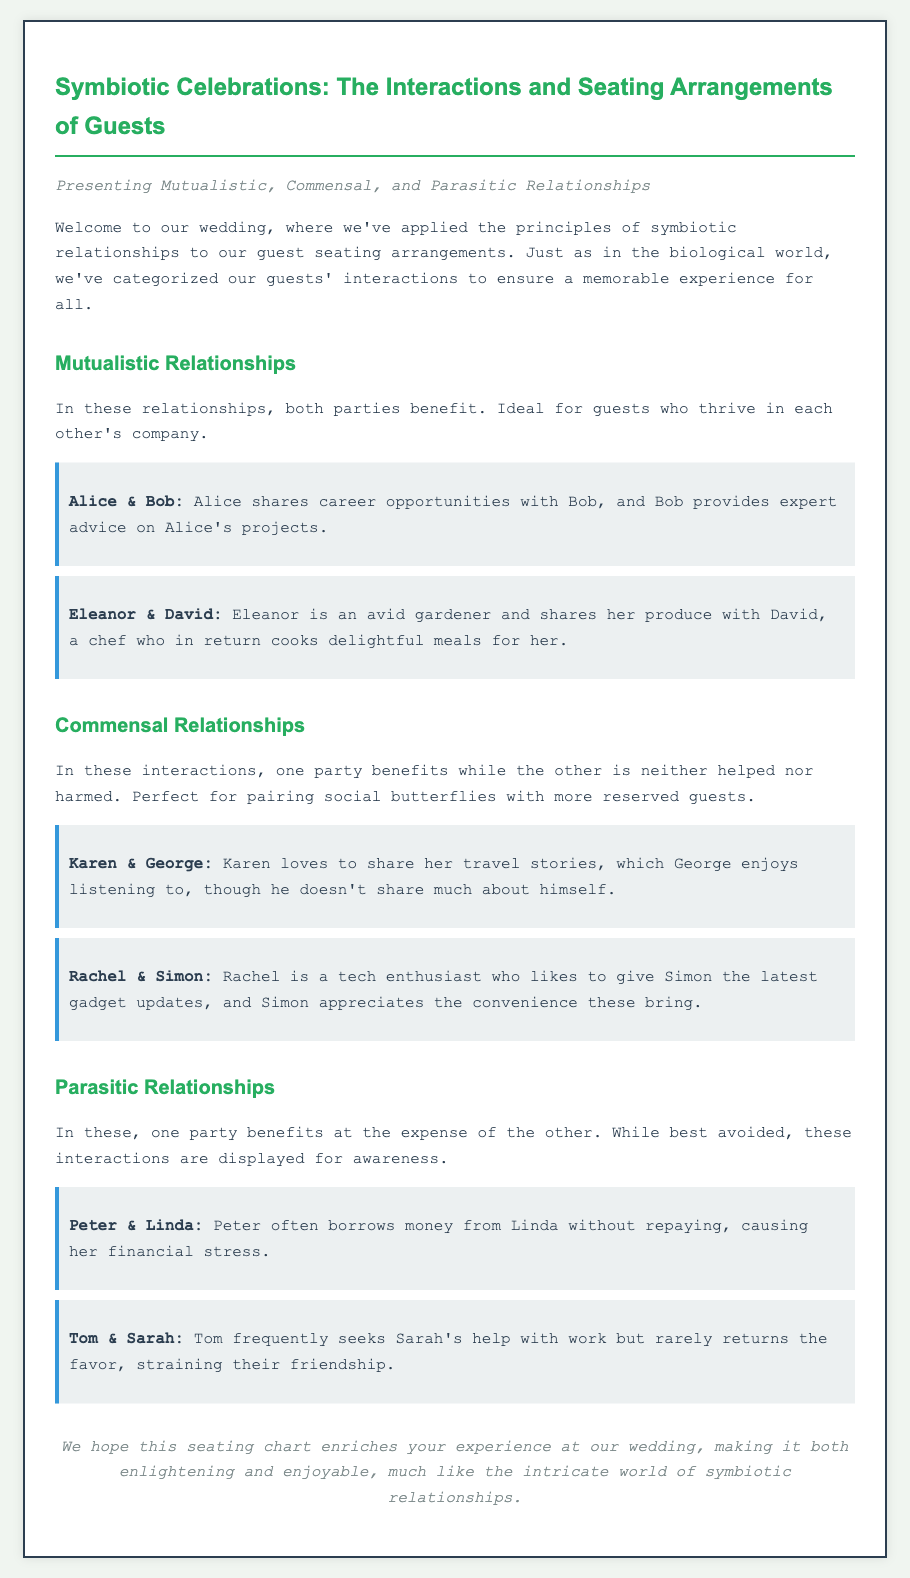What is the title of the document? The title is presented at the top of the document in the `<title>` tag.
Answer: Symbiotic Celebrations: Wedding Invitation Who are the guests in a mutualistic relationship? Mutualistic relationships are listed under the respective section and contain the names of the guests involved.
Answer: Alice & Bob, Eleanor & David What color is used for the heading text? The document's styles indicate the color for heading text defined within the CSS.
Answer: #27ae60 What type of relationship do Peter and Linda have? This information is specifically mentioned in the Parasitic Relationships section of the document.
Answer: Parasitic Which guest shares travel stories? The example describes the interaction of a guest sharing stories.
Answer: Karen 